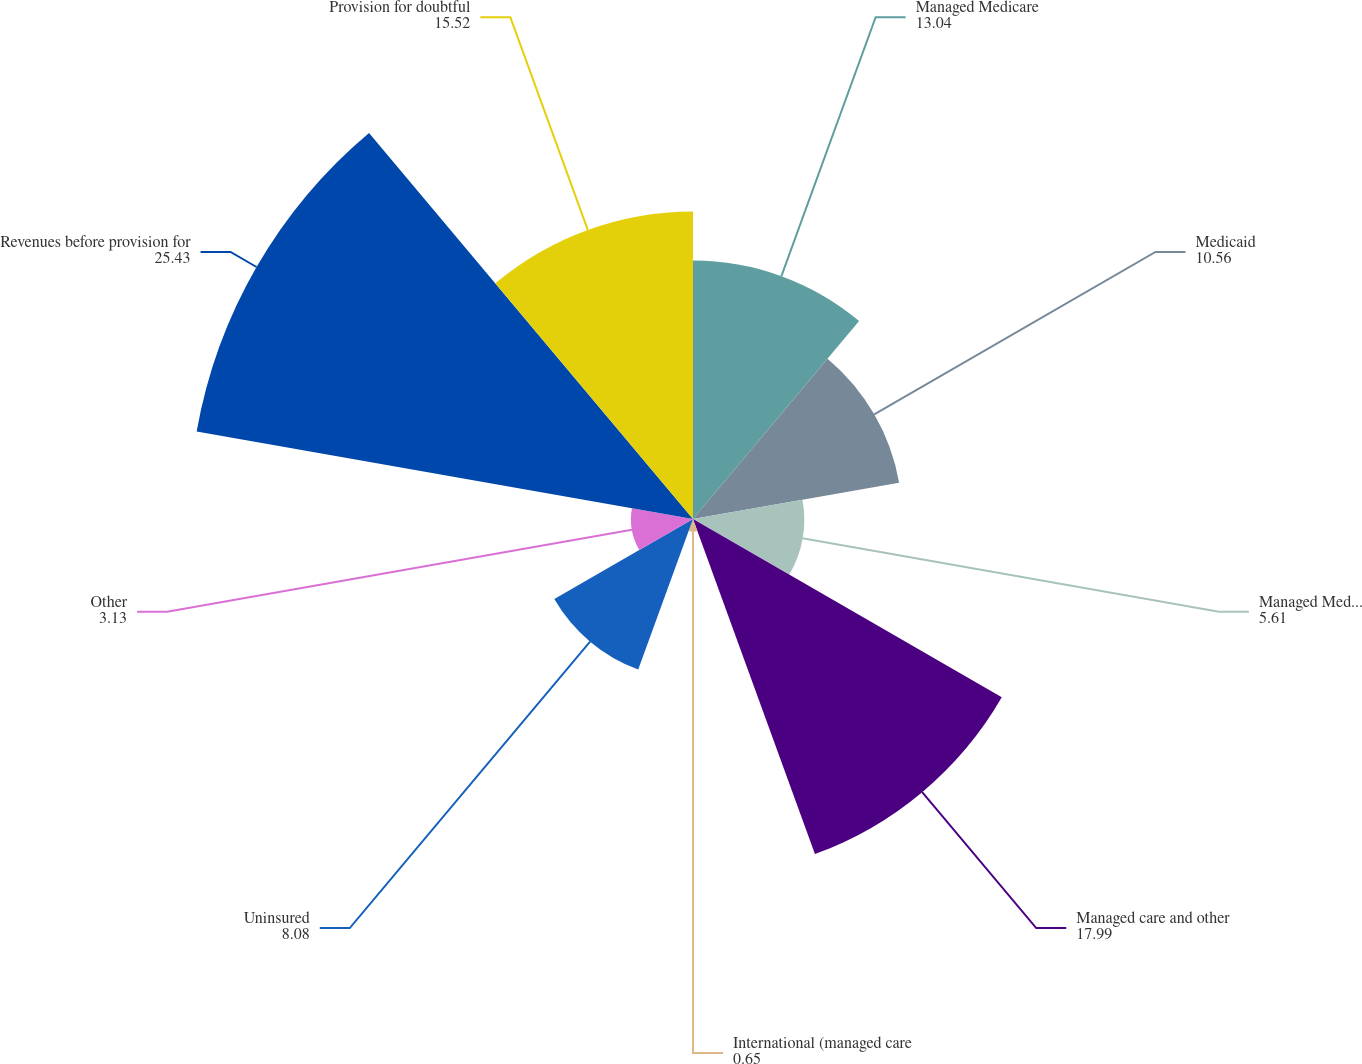Convert chart to OTSL. <chart><loc_0><loc_0><loc_500><loc_500><pie_chart><fcel>Managed Medicare<fcel>Medicaid<fcel>Managed Medicaid<fcel>Managed care and other<fcel>International (managed care<fcel>Uninsured<fcel>Other<fcel>Revenues before provision for<fcel>Provision for doubtful<nl><fcel>13.04%<fcel>10.56%<fcel>5.61%<fcel>17.99%<fcel>0.65%<fcel>8.08%<fcel>3.13%<fcel>25.43%<fcel>15.52%<nl></chart> 